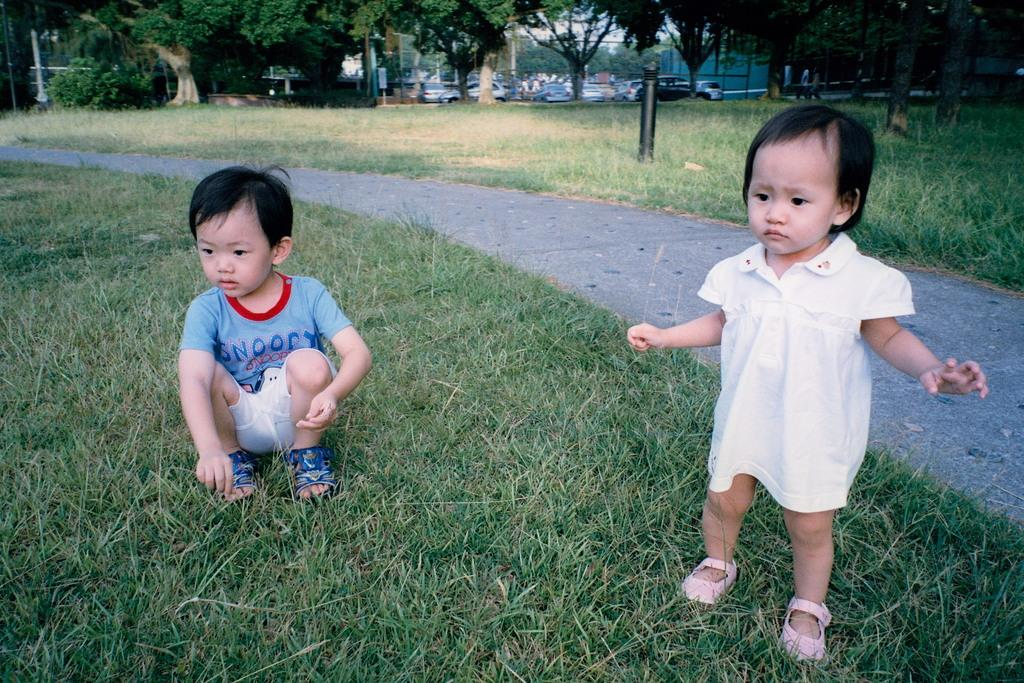<image>
Provide a brief description of the given image. Baby standing next to another baby that's wearing a shirt that says Snoopy. 